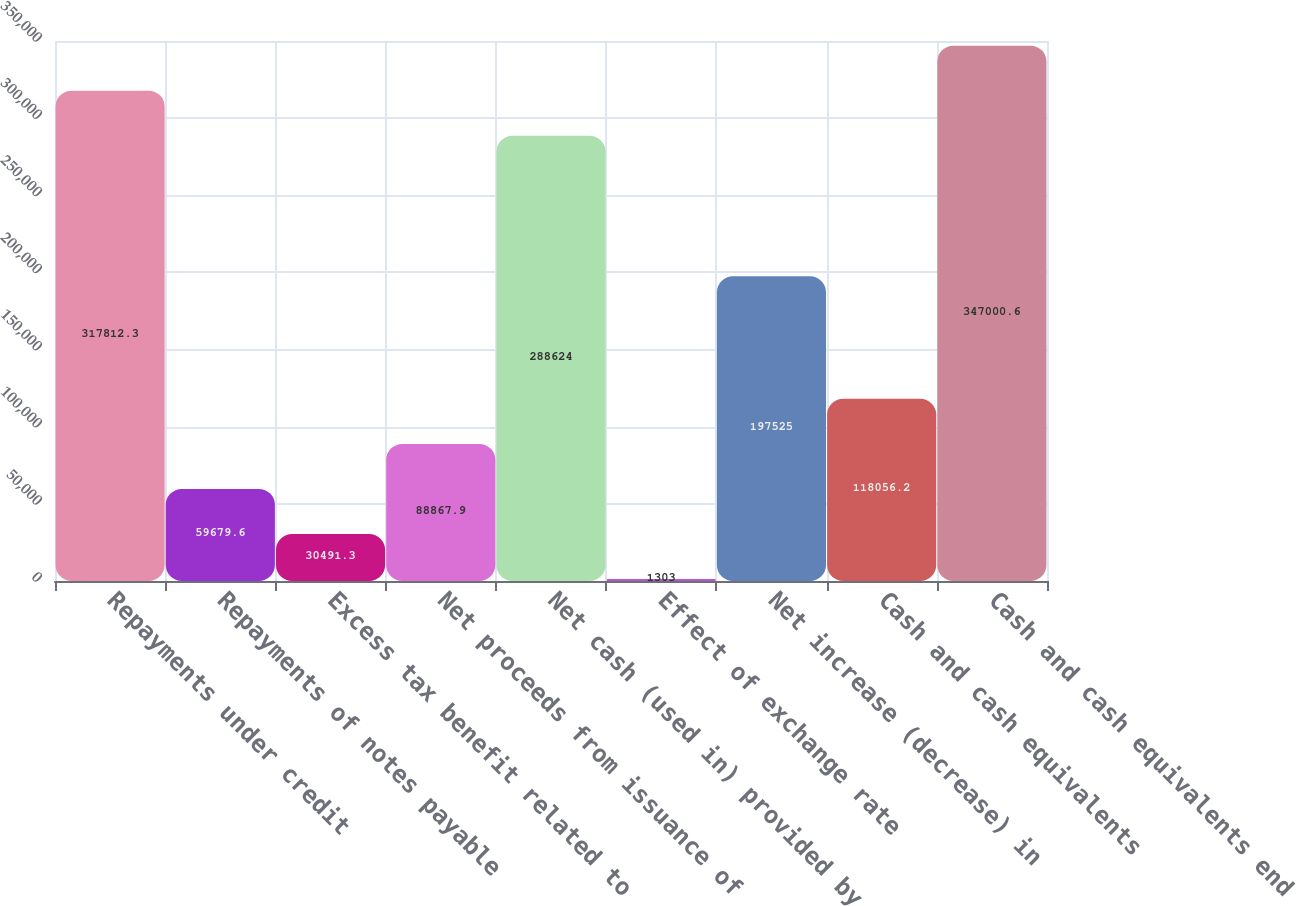Convert chart to OTSL. <chart><loc_0><loc_0><loc_500><loc_500><bar_chart><fcel>Repayments under credit<fcel>Repayments of notes payable<fcel>Excess tax benefit related to<fcel>Net proceeds from issuance of<fcel>Net cash (used in) provided by<fcel>Effect of exchange rate<fcel>Net increase (decrease) in<fcel>Cash and cash equivalents<fcel>Cash and cash equivalents end<nl><fcel>317812<fcel>59679.6<fcel>30491.3<fcel>88867.9<fcel>288624<fcel>1303<fcel>197525<fcel>118056<fcel>347001<nl></chart> 